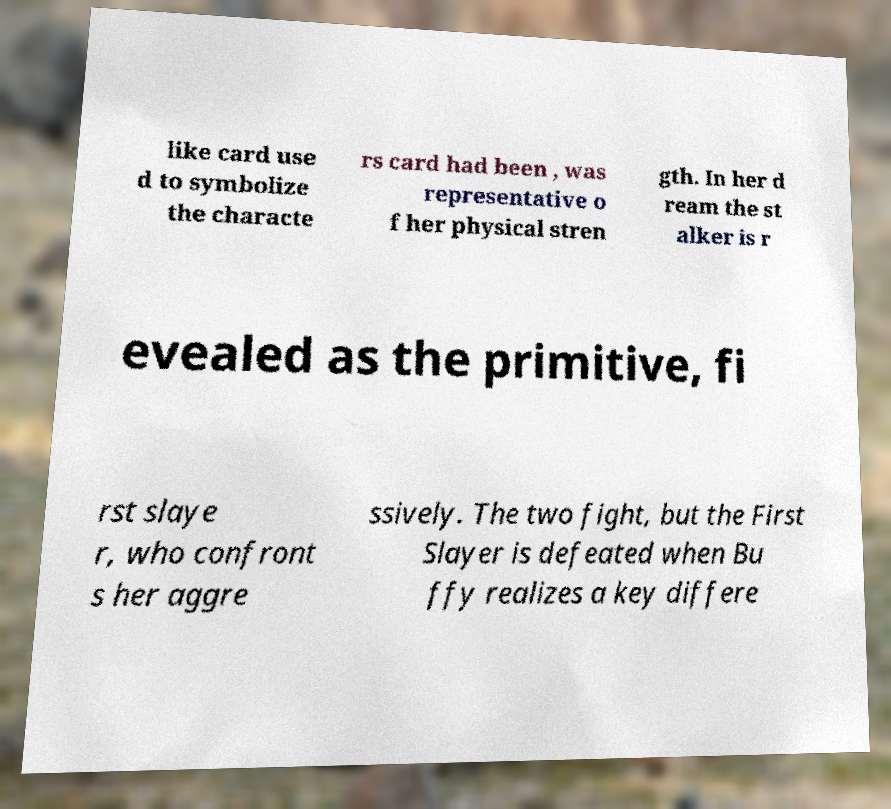What messages or text are displayed in this image? I need them in a readable, typed format. like card use d to symbolize the characte rs card had been , was representative o f her physical stren gth. In her d ream the st alker is r evealed as the primitive, fi rst slaye r, who confront s her aggre ssively. The two fight, but the First Slayer is defeated when Bu ffy realizes a key differe 